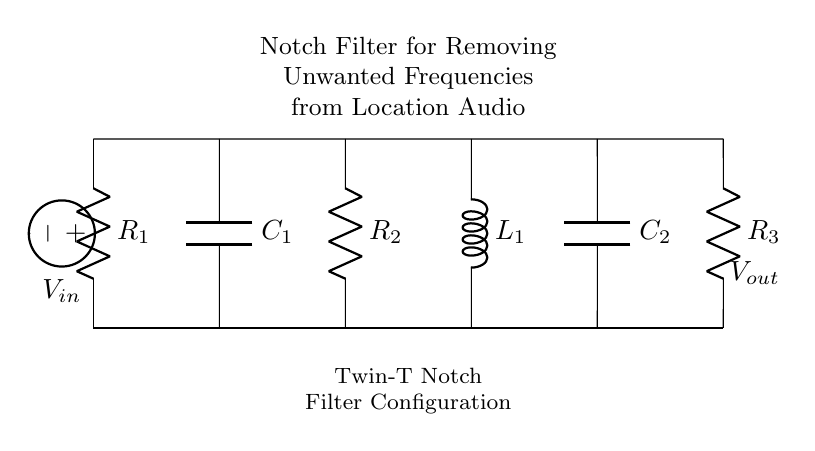What type of filter is represented in the circuit? The circuit is a notch filter, specifically a Twin-T notch filter configuration designed to eliminate certain unwanted frequencies.
Answer: Notch filter What components are used in this notch filter? The circuit contains resistors, capacitors, and an inductor. Specifically, there are three resistors, two capacitors, and one inductor.
Answer: Resistors, capacitors, inductor What is the function of the voltage source in the circuit? The voltage source provides the input voltage to the circuit that the filter processes to remove unwanted frequencies from the audio signal.
Answer: Input voltage How many resistors are in the circuit? There are a total of three resistors denoted as R1, R2, and R3 in the circuit diagram.
Answer: Three What is the purpose of the capacitors in this filter circuit? The capacitors are used to set the notch frequency along with the resistors and inductor, crucial for the filtering action of the circuit.
Answer: Set the notch frequency What happens to the output signal at the notch frequency? At the notch frequency, the output signal is significantly attenuated or reduced, effectively removing that frequency from the audio signal being processed.
Answer: Attenuated What is the configuration type shown in the circuit? The configuration follows a Twin-T topology which is commonly used for implementing notch filters in audio applications.
Answer: Twin-T 